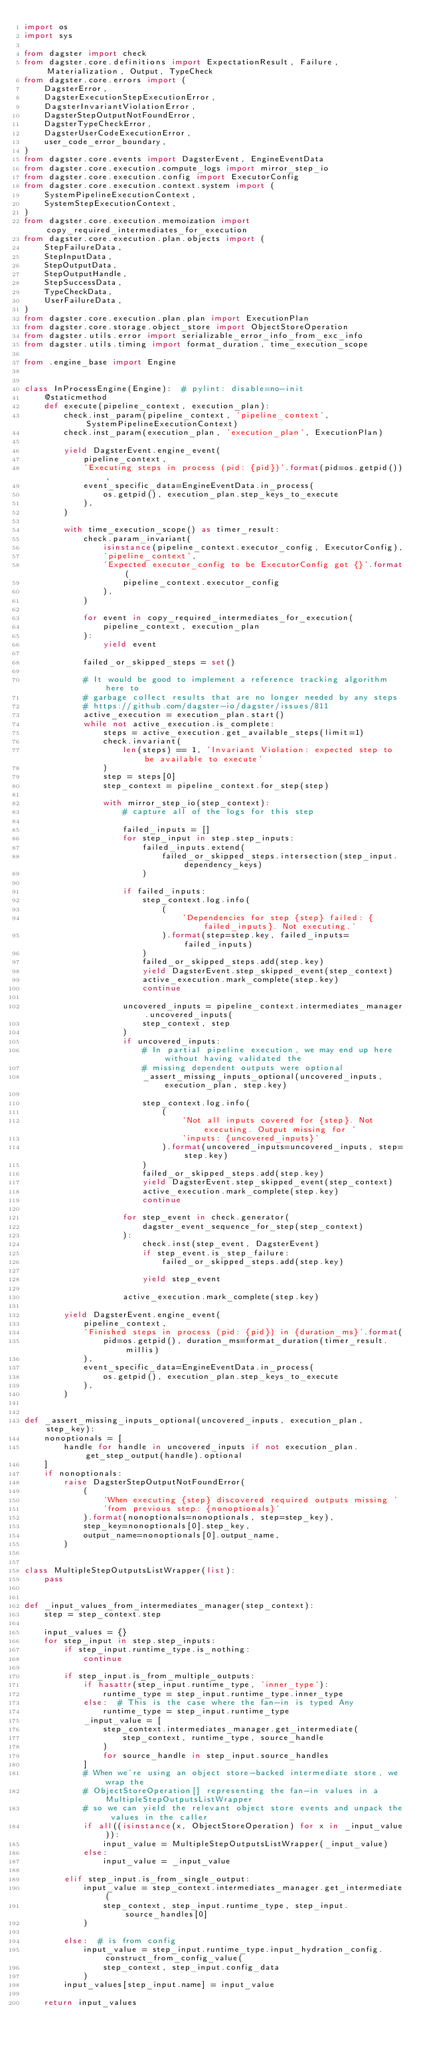Convert code to text. <code><loc_0><loc_0><loc_500><loc_500><_Python_>import os
import sys

from dagster import check
from dagster.core.definitions import ExpectationResult, Failure, Materialization, Output, TypeCheck
from dagster.core.errors import (
    DagsterError,
    DagsterExecutionStepExecutionError,
    DagsterInvariantViolationError,
    DagsterStepOutputNotFoundError,
    DagsterTypeCheckError,
    DagsterUserCodeExecutionError,
    user_code_error_boundary,
)
from dagster.core.events import DagsterEvent, EngineEventData
from dagster.core.execution.compute_logs import mirror_step_io
from dagster.core.execution.config import ExecutorConfig
from dagster.core.execution.context.system import (
    SystemPipelineExecutionContext,
    SystemStepExecutionContext,
)
from dagster.core.execution.memoization import copy_required_intermediates_for_execution
from dagster.core.execution.plan.objects import (
    StepFailureData,
    StepInputData,
    StepOutputData,
    StepOutputHandle,
    StepSuccessData,
    TypeCheckData,
    UserFailureData,
)
from dagster.core.execution.plan.plan import ExecutionPlan
from dagster.core.storage.object_store import ObjectStoreOperation
from dagster.utils.error import serializable_error_info_from_exc_info
from dagster.utils.timing import format_duration, time_execution_scope

from .engine_base import Engine


class InProcessEngine(Engine):  # pylint: disable=no-init
    @staticmethod
    def execute(pipeline_context, execution_plan):
        check.inst_param(pipeline_context, 'pipeline_context', SystemPipelineExecutionContext)
        check.inst_param(execution_plan, 'execution_plan', ExecutionPlan)

        yield DagsterEvent.engine_event(
            pipeline_context,
            'Executing steps in process (pid: {pid})'.format(pid=os.getpid()),
            event_specific_data=EngineEventData.in_process(
                os.getpid(), execution_plan.step_keys_to_execute
            ),
        )

        with time_execution_scope() as timer_result:
            check.param_invariant(
                isinstance(pipeline_context.executor_config, ExecutorConfig),
                'pipeline_context',
                'Expected executor_config to be ExecutorConfig got {}'.format(
                    pipeline_context.executor_config
                ),
            )

            for event in copy_required_intermediates_for_execution(
                pipeline_context, execution_plan
            ):
                yield event

            failed_or_skipped_steps = set()

            # It would be good to implement a reference tracking algorithm here to
            # garbage collect results that are no longer needed by any steps
            # https://github.com/dagster-io/dagster/issues/811
            active_execution = execution_plan.start()
            while not active_execution.is_complete:
                steps = active_execution.get_available_steps(limit=1)
                check.invariant(
                    len(steps) == 1, 'Invariant Violation: expected step to be available to execute'
                )
                step = steps[0]
                step_context = pipeline_context.for_step(step)

                with mirror_step_io(step_context):
                    # capture all of the logs for this step

                    failed_inputs = []
                    for step_input in step.step_inputs:
                        failed_inputs.extend(
                            failed_or_skipped_steps.intersection(step_input.dependency_keys)
                        )

                    if failed_inputs:
                        step_context.log.info(
                            (
                                'Dependencies for step {step} failed: {failed_inputs}. Not executing.'
                            ).format(step=step.key, failed_inputs=failed_inputs)
                        )
                        failed_or_skipped_steps.add(step.key)
                        yield DagsterEvent.step_skipped_event(step_context)
                        active_execution.mark_complete(step.key)
                        continue

                    uncovered_inputs = pipeline_context.intermediates_manager.uncovered_inputs(
                        step_context, step
                    )
                    if uncovered_inputs:
                        # In partial pipeline execution, we may end up here without having validated the
                        # missing dependent outputs were optional
                        _assert_missing_inputs_optional(uncovered_inputs, execution_plan, step.key)

                        step_context.log.info(
                            (
                                'Not all inputs covered for {step}. Not executing. Output missing for '
                                'inputs: {uncovered_inputs}'
                            ).format(uncovered_inputs=uncovered_inputs, step=step.key)
                        )
                        failed_or_skipped_steps.add(step.key)
                        yield DagsterEvent.step_skipped_event(step_context)
                        active_execution.mark_complete(step.key)
                        continue

                    for step_event in check.generator(
                        dagster_event_sequence_for_step(step_context)
                    ):
                        check.inst(step_event, DagsterEvent)
                        if step_event.is_step_failure:
                            failed_or_skipped_steps.add(step.key)

                        yield step_event

                    active_execution.mark_complete(step.key)

        yield DagsterEvent.engine_event(
            pipeline_context,
            'Finished steps in process (pid: {pid}) in {duration_ms}'.format(
                pid=os.getpid(), duration_ms=format_duration(timer_result.millis)
            ),
            event_specific_data=EngineEventData.in_process(
                os.getpid(), execution_plan.step_keys_to_execute
            ),
        )


def _assert_missing_inputs_optional(uncovered_inputs, execution_plan, step_key):
    nonoptionals = [
        handle for handle in uncovered_inputs if not execution_plan.get_step_output(handle).optional
    ]
    if nonoptionals:
        raise DagsterStepOutputNotFoundError(
            (
                'When executing {step} discovered required outputs missing '
                'from previous step: {nonoptionals}'
            ).format(nonoptionals=nonoptionals, step=step_key),
            step_key=nonoptionals[0].step_key,
            output_name=nonoptionals[0].output_name,
        )


class MultipleStepOutputsListWrapper(list):
    pass


def _input_values_from_intermediates_manager(step_context):
    step = step_context.step

    input_values = {}
    for step_input in step.step_inputs:
        if step_input.runtime_type.is_nothing:
            continue

        if step_input.is_from_multiple_outputs:
            if hasattr(step_input.runtime_type, 'inner_type'):
                runtime_type = step_input.runtime_type.inner_type
            else:  # This is the case where the fan-in is typed Any
                runtime_type = step_input.runtime_type
            _input_value = [
                step_context.intermediates_manager.get_intermediate(
                    step_context, runtime_type, source_handle
                )
                for source_handle in step_input.source_handles
            ]
            # When we're using an object store-backed intermediate store, we wrap the
            # ObjectStoreOperation[] representing the fan-in values in a MultipleStepOutputsListWrapper
            # so we can yield the relevant object store events and unpack the values in the caller
            if all((isinstance(x, ObjectStoreOperation) for x in _input_value)):
                input_value = MultipleStepOutputsListWrapper(_input_value)
            else:
                input_value = _input_value

        elif step_input.is_from_single_output:
            input_value = step_context.intermediates_manager.get_intermediate(
                step_context, step_input.runtime_type, step_input.source_handles[0]
            )

        else:  # is from config
            input_value = step_input.runtime_type.input_hydration_config.construct_from_config_value(
                step_context, step_input.config_data
            )
        input_values[step_input.name] = input_value

    return input_values

</code> 